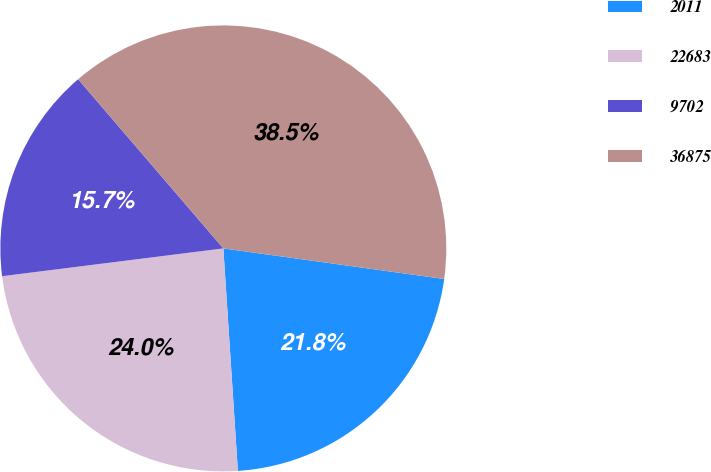<chart> <loc_0><loc_0><loc_500><loc_500><pie_chart><fcel>2011<fcel>22683<fcel>9702<fcel>36875<nl><fcel>21.77%<fcel>24.05%<fcel>15.7%<fcel>38.48%<nl></chart> 